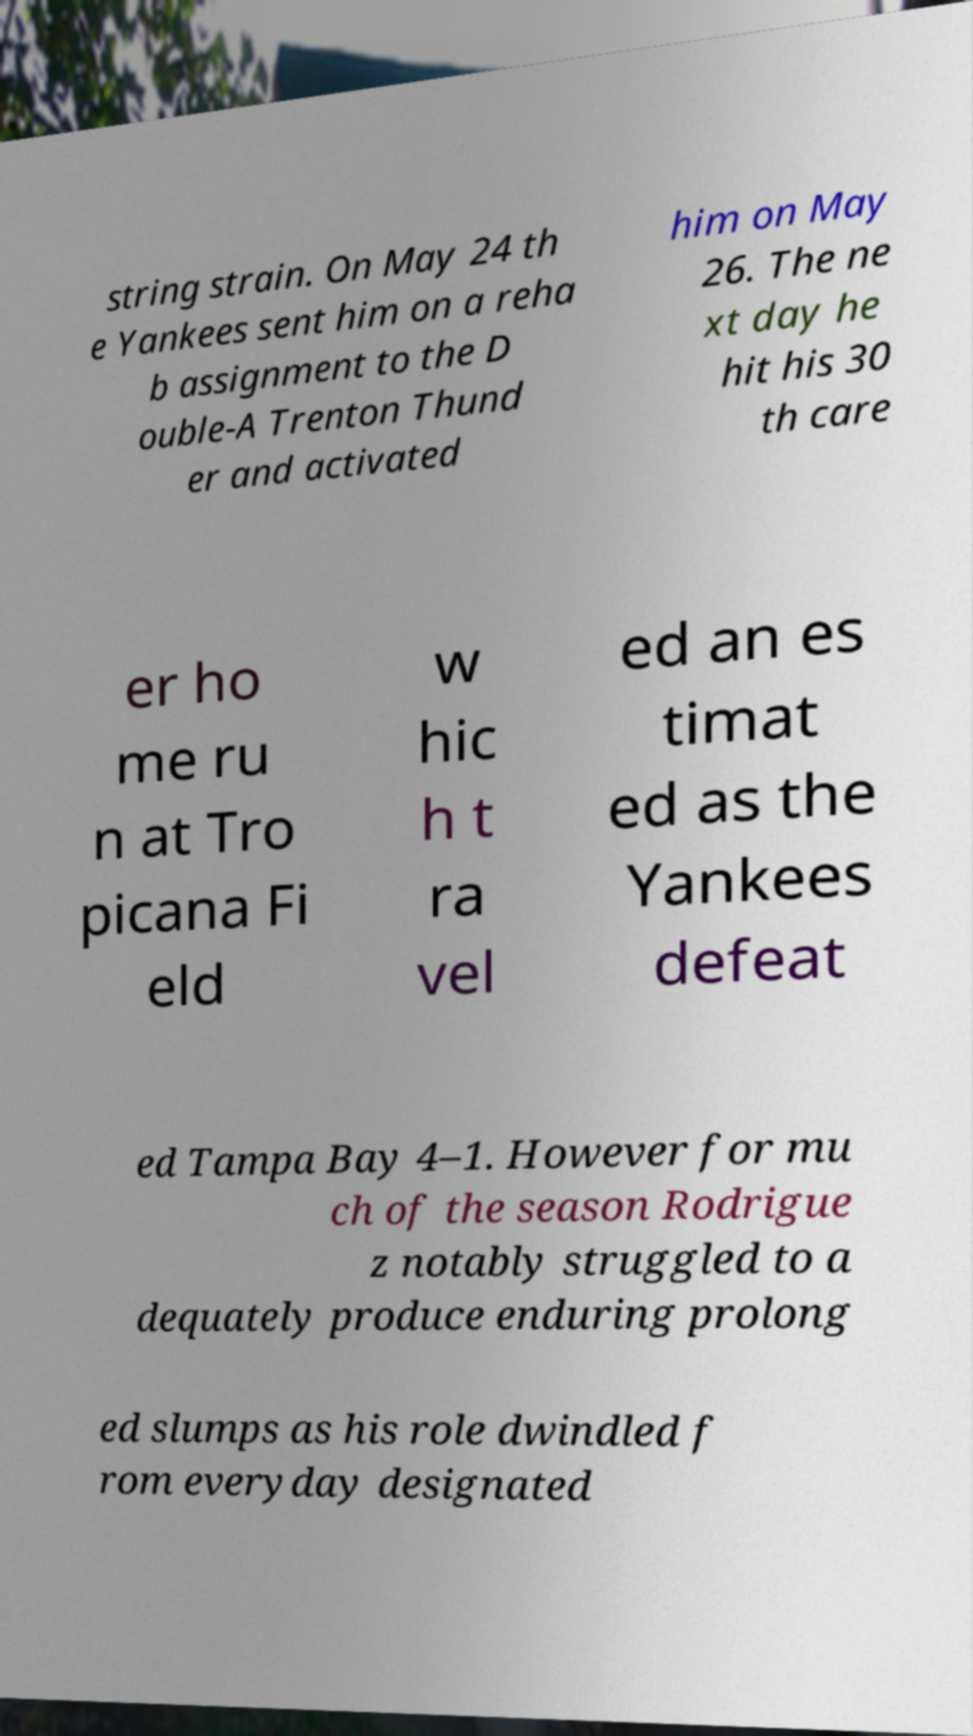What messages or text are displayed in this image? I need them in a readable, typed format. string strain. On May 24 th e Yankees sent him on a reha b assignment to the D ouble-A Trenton Thund er and activated him on May 26. The ne xt day he hit his 30 th care er ho me ru n at Tro picana Fi eld w hic h t ra vel ed an es timat ed as the Yankees defeat ed Tampa Bay 4–1. However for mu ch of the season Rodrigue z notably struggled to a dequately produce enduring prolong ed slumps as his role dwindled f rom everyday designated 